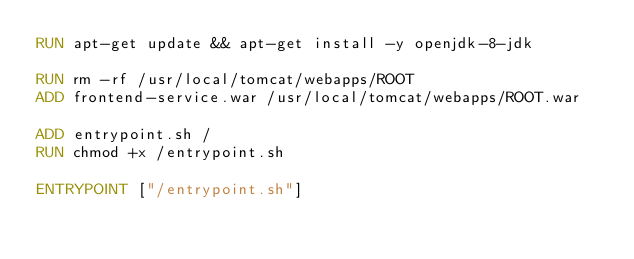<code> <loc_0><loc_0><loc_500><loc_500><_Dockerfile_>RUN apt-get update && apt-get install -y openjdk-8-jdk

RUN rm -rf /usr/local/tomcat/webapps/ROOT
ADD frontend-service.war /usr/local/tomcat/webapps/ROOT.war

ADD entrypoint.sh /
RUN chmod +x /entrypoint.sh

ENTRYPOINT ["/entrypoint.sh"]</code> 